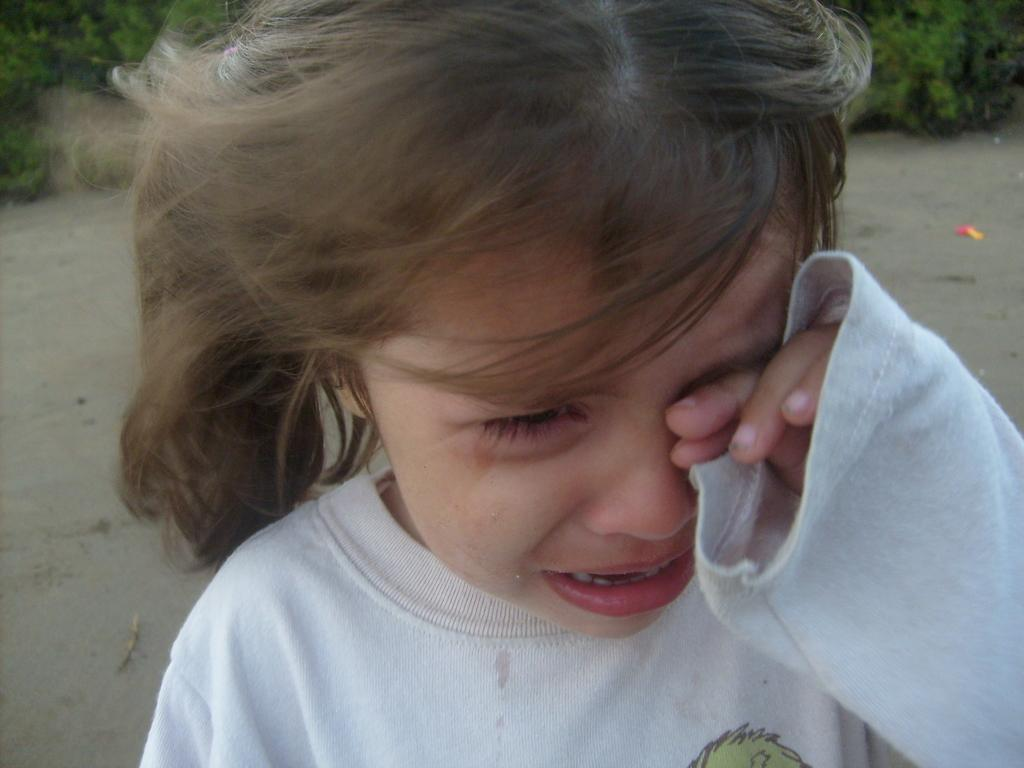Who is the main subject in the image? There is a girl in the image. What is the girl wearing? The girl is wearing a white t-shirt. What emotion is the girl displaying in the image? The girl is crying. What can be seen in the background of the image? There is a path and green plants visible in the background. How many chairs are visible in the image? There are no chairs present in the image. What type of bird can be seen perched on the girl's shoulder in the image? There is no bird visible in the image, let alone a robin. 